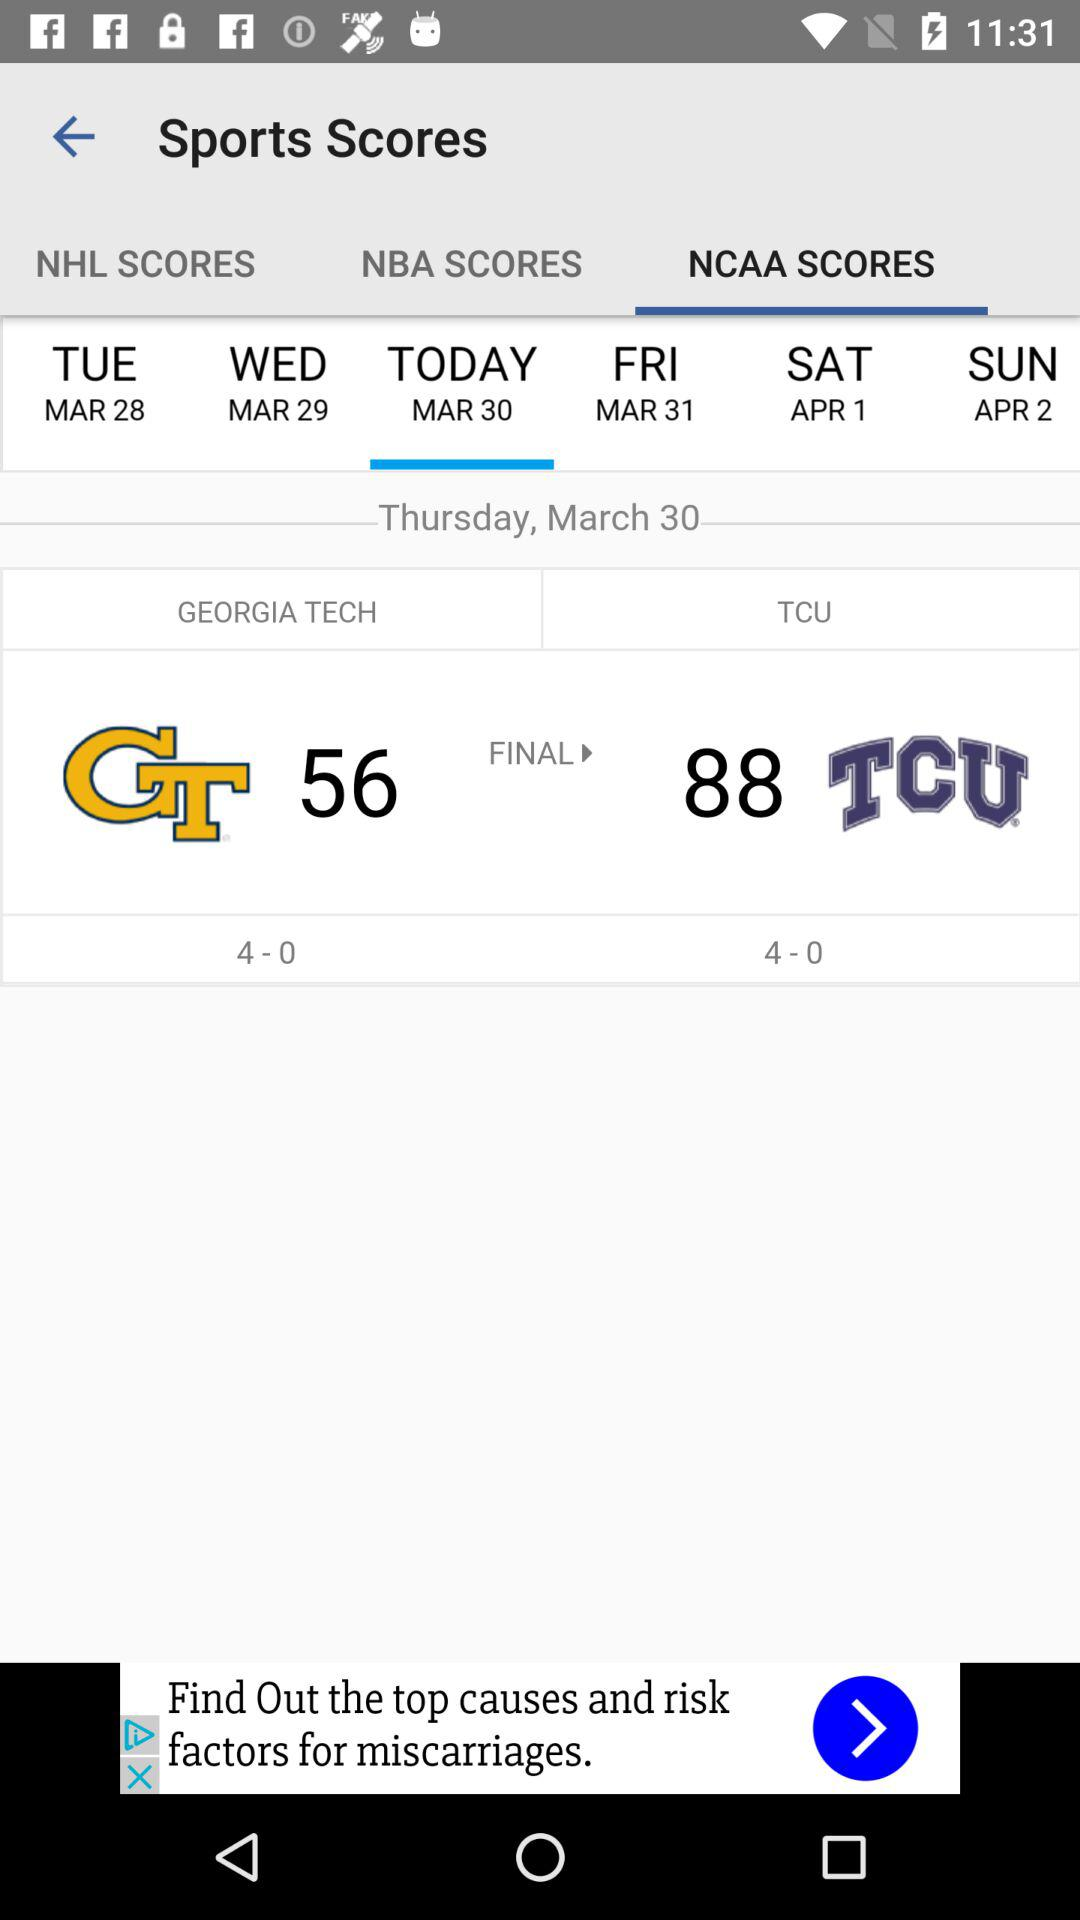How many teams have a 4-0 record?
Answer the question using a single word or phrase. 2 